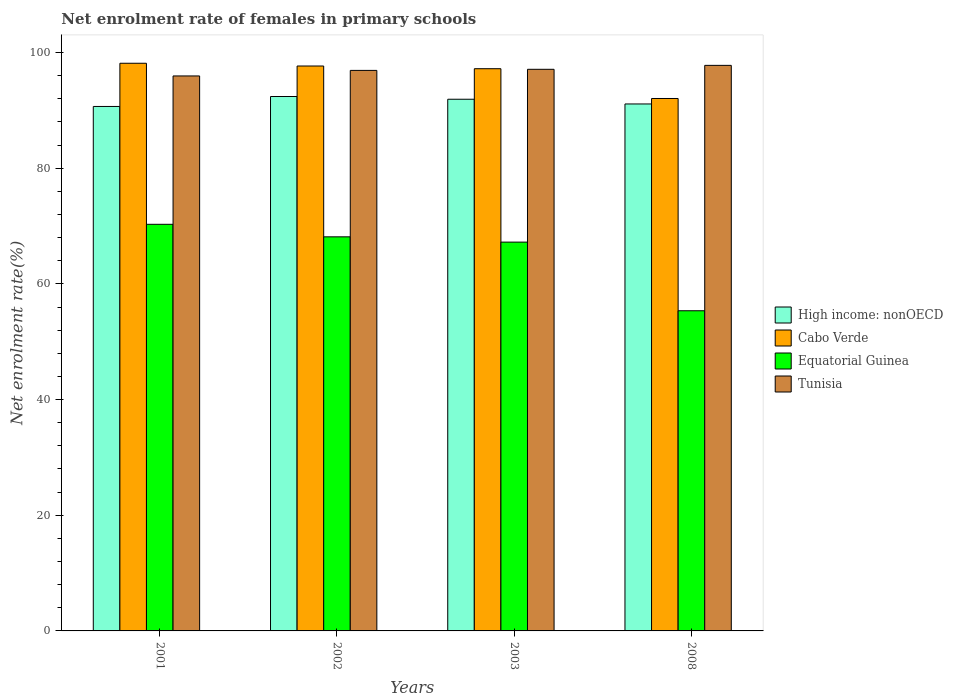Are the number of bars per tick equal to the number of legend labels?
Offer a very short reply. Yes. How many bars are there on the 1st tick from the left?
Provide a succinct answer. 4. How many bars are there on the 2nd tick from the right?
Offer a very short reply. 4. What is the label of the 3rd group of bars from the left?
Your answer should be compact. 2003. In how many cases, is the number of bars for a given year not equal to the number of legend labels?
Your answer should be compact. 0. What is the net enrolment rate of females in primary schools in Cabo Verde in 2008?
Ensure brevity in your answer.  92.05. Across all years, what is the maximum net enrolment rate of females in primary schools in Cabo Verde?
Give a very brief answer. 98.14. Across all years, what is the minimum net enrolment rate of females in primary schools in Cabo Verde?
Provide a succinct answer. 92.05. In which year was the net enrolment rate of females in primary schools in Cabo Verde maximum?
Your response must be concise. 2001. What is the total net enrolment rate of females in primary schools in Equatorial Guinea in the graph?
Your answer should be compact. 261. What is the difference between the net enrolment rate of females in primary schools in Tunisia in 2003 and that in 2008?
Offer a terse response. -0.68. What is the difference between the net enrolment rate of females in primary schools in Cabo Verde in 2001 and the net enrolment rate of females in primary schools in Tunisia in 2002?
Your answer should be very brief. 1.24. What is the average net enrolment rate of females in primary schools in Tunisia per year?
Provide a succinct answer. 96.93. In the year 2008, what is the difference between the net enrolment rate of females in primary schools in High income: nonOECD and net enrolment rate of females in primary schools in Tunisia?
Your answer should be compact. -6.67. In how many years, is the net enrolment rate of females in primary schools in Equatorial Guinea greater than 92 %?
Your answer should be compact. 0. What is the ratio of the net enrolment rate of females in primary schools in Cabo Verde in 2001 to that in 2003?
Provide a succinct answer. 1.01. Is the net enrolment rate of females in primary schools in Equatorial Guinea in 2001 less than that in 2002?
Ensure brevity in your answer.  No. What is the difference between the highest and the second highest net enrolment rate of females in primary schools in Equatorial Guinea?
Your answer should be very brief. 2.17. What is the difference between the highest and the lowest net enrolment rate of females in primary schools in Tunisia?
Your answer should be compact. 1.83. Is the sum of the net enrolment rate of females in primary schools in Tunisia in 2003 and 2008 greater than the maximum net enrolment rate of females in primary schools in Cabo Verde across all years?
Ensure brevity in your answer.  Yes. What does the 2nd bar from the left in 2003 represents?
Make the answer very short. Cabo Verde. What does the 4th bar from the right in 2008 represents?
Make the answer very short. High income: nonOECD. Are all the bars in the graph horizontal?
Offer a terse response. No. How many years are there in the graph?
Your answer should be compact. 4. Does the graph contain any zero values?
Make the answer very short. No. How are the legend labels stacked?
Your answer should be compact. Vertical. What is the title of the graph?
Ensure brevity in your answer.  Net enrolment rate of females in primary schools. Does "Paraguay" appear as one of the legend labels in the graph?
Your response must be concise. No. What is the label or title of the X-axis?
Offer a very short reply. Years. What is the label or title of the Y-axis?
Ensure brevity in your answer.  Net enrolment rate(%). What is the Net enrolment rate(%) in High income: nonOECD in 2001?
Provide a short and direct response. 90.67. What is the Net enrolment rate(%) of Cabo Verde in 2001?
Offer a terse response. 98.14. What is the Net enrolment rate(%) of Equatorial Guinea in 2001?
Keep it short and to the point. 70.3. What is the Net enrolment rate(%) in Tunisia in 2001?
Offer a very short reply. 95.95. What is the Net enrolment rate(%) in High income: nonOECD in 2002?
Provide a short and direct response. 92.39. What is the Net enrolment rate(%) in Cabo Verde in 2002?
Provide a short and direct response. 97.66. What is the Net enrolment rate(%) in Equatorial Guinea in 2002?
Make the answer very short. 68.13. What is the Net enrolment rate(%) in Tunisia in 2002?
Your response must be concise. 96.9. What is the Net enrolment rate(%) of High income: nonOECD in 2003?
Make the answer very short. 91.92. What is the Net enrolment rate(%) in Cabo Verde in 2003?
Give a very brief answer. 97.2. What is the Net enrolment rate(%) of Equatorial Guinea in 2003?
Your response must be concise. 67.22. What is the Net enrolment rate(%) in Tunisia in 2003?
Provide a succinct answer. 97.09. What is the Net enrolment rate(%) in High income: nonOECD in 2008?
Provide a succinct answer. 91.1. What is the Net enrolment rate(%) in Cabo Verde in 2008?
Keep it short and to the point. 92.05. What is the Net enrolment rate(%) of Equatorial Guinea in 2008?
Provide a succinct answer. 55.35. What is the Net enrolment rate(%) of Tunisia in 2008?
Provide a succinct answer. 97.77. Across all years, what is the maximum Net enrolment rate(%) in High income: nonOECD?
Make the answer very short. 92.39. Across all years, what is the maximum Net enrolment rate(%) of Cabo Verde?
Give a very brief answer. 98.14. Across all years, what is the maximum Net enrolment rate(%) of Equatorial Guinea?
Ensure brevity in your answer.  70.3. Across all years, what is the maximum Net enrolment rate(%) of Tunisia?
Provide a short and direct response. 97.77. Across all years, what is the minimum Net enrolment rate(%) in High income: nonOECD?
Offer a terse response. 90.67. Across all years, what is the minimum Net enrolment rate(%) of Cabo Verde?
Provide a succinct answer. 92.05. Across all years, what is the minimum Net enrolment rate(%) in Equatorial Guinea?
Keep it short and to the point. 55.35. Across all years, what is the minimum Net enrolment rate(%) in Tunisia?
Your response must be concise. 95.95. What is the total Net enrolment rate(%) of High income: nonOECD in the graph?
Your response must be concise. 366.08. What is the total Net enrolment rate(%) in Cabo Verde in the graph?
Your response must be concise. 385.05. What is the total Net enrolment rate(%) of Equatorial Guinea in the graph?
Provide a short and direct response. 261. What is the total Net enrolment rate(%) of Tunisia in the graph?
Provide a short and direct response. 387.72. What is the difference between the Net enrolment rate(%) of High income: nonOECD in 2001 and that in 2002?
Offer a very short reply. -1.72. What is the difference between the Net enrolment rate(%) of Cabo Verde in 2001 and that in 2002?
Your answer should be very brief. 0.48. What is the difference between the Net enrolment rate(%) in Equatorial Guinea in 2001 and that in 2002?
Ensure brevity in your answer.  2.17. What is the difference between the Net enrolment rate(%) in Tunisia in 2001 and that in 2002?
Ensure brevity in your answer.  -0.96. What is the difference between the Net enrolment rate(%) in High income: nonOECD in 2001 and that in 2003?
Your answer should be compact. -1.25. What is the difference between the Net enrolment rate(%) of Cabo Verde in 2001 and that in 2003?
Give a very brief answer. 0.94. What is the difference between the Net enrolment rate(%) in Equatorial Guinea in 2001 and that in 2003?
Provide a succinct answer. 3.08. What is the difference between the Net enrolment rate(%) in Tunisia in 2001 and that in 2003?
Your answer should be very brief. -1.15. What is the difference between the Net enrolment rate(%) in High income: nonOECD in 2001 and that in 2008?
Ensure brevity in your answer.  -0.43. What is the difference between the Net enrolment rate(%) in Cabo Verde in 2001 and that in 2008?
Provide a short and direct response. 6.09. What is the difference between the Net enrolment rate(%) in Equatorial Guinea in 2001 and that in 2008?
Keep it short and to the point. 14.95. What is the difference between the Net enrolment rate(%) in Tunisia in 2001 and that in 2008?
Provide a short and direct response. -1.83. What is the difference between the Net enrolment rate(%) of High income: nonOECD in 2002 and that in 2003?
Your response must be concise. 0.47. What is the difference between the Net enrolment rate(%) of Cabo Verde in 2002 and that in 2003?
Ensure brevity in your answer.  0.47. What is the difference between the Net enrolment rate(%) in Equatorial Guinea in 2002 and that in 2003?
Give a very brief answer. 0.91. What is the difference between the Net enrolment rate(%) of Tunisia in 2002 and that in 2003?
Ensure brevity in your answer.  -0.19. What is the difference between the Net enrolment rate(%) in High income: nonOECD in 2002 and that in 2008?
Ensure brevity in your answer.  1.29. What is the difference between the Net enrolment rate(%) in Cabo Verde in 2002 and that in 2008?
Provide a short and direct response. 5.62. What is the difference between the Net enrolment rate(%) of Equatorial Guinea in 2002 and that in 2008?
Provide a succinct answer. 12.78. What is the difference between the Net enrolment rate(%) in Tunisia in 2002 and that in 2008?
Keep it short and to the point. -0.87. What is the difference between the Net enrolment rate(%) of High income: nonOECD in 2003 and that in 2008?
Your answer should be very brief. 0.81. What is the difference between the Net enrolment rate(%) of Cabo Verde in 2003 and that in 2008?
Your answer should be very brief. 5.15. What is the difference between the Net enrolment rate(%) of Equatorial Guinea in 2003 and that in 2008?
Make the answer very short. 11.87. What is the difference between the Net enrolment rate(%) in Tunisia in 2003 and that in 2008?
Keep it short and to the point. -0.68. What is the difference between the Net enrolment rate(%) of High income: nonOECD in 2001 and the Net enrolment rate(%) of Cabo Verde in 2002?
Provide a succinct answer. -6.99. What is the difference between the Net enrolment rate(%) in High income: nonOECD in 2001 and the Net enrolment rate(%) in Equatorial Guinea in 2002?
Provide a short and direct response. 22.54. What is the difference between the Net enrolment rate(%) of High income: nonOECD in 2001 and the Net enrolment rate(%) of Tunisia in 2002?
Your response must be concise. -6.23. What is the difference between the Net enrolment rate(%) in Cabo Verde in 2001 and the Net enrolment rate(%) in Equatorial Guinea in 2002?
Provide a short and direct response. 30.01. What is the difference between the Net enrolment rate(%) in Cabo Verde in 2001 and the Net enrolment rate(%) in Tunisia in 2002?
Your answer should be compact. 1.24. What is the difference between the Net enrolment rate(%) of Equatorial Guinea in 2001 and the Net enrolment rate(%) of Tunisia in 2002?
Make the answer very short. -26.61. What is the difference between the Net enrolment rate(%) of High income: nonOECD in 2001 and the Net enrolment rate(%) of Cabo Verde in 2003?
Provide a short and direct response. -6.53. What is the difference between the Net enrolment rate(%) in High income: nonOECD in 2001 and the Net enrolment rate(%) in Equatorial Guinea in 2003?
Provide a short and direct response. 23.45. What is the difference between the Net enrolment rate(%) of High income: nonOECD in 2001 and the Net enrolment rate(%) of Tunisia in 2003?
Keep it short and to the point. -6.42. What is the difference between the Net enrolment rate(%) in Cabo Verde in 2001 and the Net enrolment rate(%) in Equatorial Guinea in 2003?
Your answer should be very brief. 30.92. What is the difference between the Net enrolment rate(%) in Cabo Verde in 2001 and the Net enrolment rate(%) in Tunisia in 2003?
Make the answer very short. 1.05. What is the difference between the Net enrolment rate(%) in Equatorial Guinea in 2001 and the Net enrolment rate(%) in Tunisia in 2003?
Make the answer very short. -26.79. What is the difference between the Net enrolment rate(%) in High income: nonOECD in 2001 and the Net enrolment rate(%) in Cabo Verde in 2008?
Provide a short and direct response. -1.38. What is the difference between the Net enrolment rate(%) of High income: nonOECD in 2001 and the Net enrolment rate(%) of Equatorial Guinea in 2008?
Provide a succinct answer. 35.32. What is the difference between the Net enrolment rate(%) of High income: nonOECD in 2001 and the Net enrolment rate(%) of Tunisia in 2008?
Provide a short and direct response. -7.1. What is the difference between the Net enrolment rate(%) in Cabo Verde in 2001 and the Net enrolment rate(%) in Equatorial Guinea in 2008?
Keep it short and to the point. 42.79. What is the difference between the Net enrolment rate(%) of Cabo Verde in 2001 and the Net enrolment rate(%) of Tunisia in 2008?
Your answer should be compact. 0.37. What is the difference between the Net enrolment rate(%) of Equatorial Guinea in 2001 and the Net enrolment rate(%) of Tunisia in 2008?
Provide a short and direct response. -27.48. What is the difference between the Net enrolment rate(%) of High income: nonOECD in 2002 and the Net enrolment rate(%) of Cabo Verde in 2003?
Provide a succinct answer. -4.81. What is the difference between the Net enrolment rate(%) of High income: nonOECD in 2002 and the Net enrolment rate(%) of Equatorial Guinea in 2003?
Offer a terse response. 25.17. What is the difference between the Net enrolment rate(%) in High income: nonOECD in 2002 and the Net enrolment rate(%) in Tunisia in 2003?
Make the answer very short. -4.7. What is the difference between the Net enrolment rate(%) of Cabo Verde in 2002 and the Net enrolment rate(%) of Equatorial Guinea in 2003?
Offer a terse response. 30.45. What is the difference between the Net enrolment rate(%) of Cabo Verde in 2002 and the Net enrolment rate(%) of Tunisia in 2003?
Provide a short and direct response. 0.57. What is the difference between the Net enrolment rate(%) in Equatorial Guinea in 2002 and the Net enrolment rate(%) in Tunisia in 2003?
Give a very brief answer. -28.96. What is the difference between the Net enrolment rate(%) in High income: nonOECD in 2002 and the Net enrolment rate(%) in Cabo Verde in 2008?
Ensure brevity in your answer.  0.34. What is the difference between the Net enrolment rate(%) of High income: nonOECD in 2002 and the Net enrolment rate(%) of Equatorial Guinea in 2008?
Provide a succinct answer. 37.04. What is the difference between the Net enrolment rate(%) of High income: nonOECD in 2002 and the Net enrolment rate(%) of Tunisia in 2008?
Provide a succinct answer. -5.38. What is the difference between the Net enrolment rate(%) of Cabo Verde in 2002 and the Net enrolment rate(%) of Equatorial Guinea in 2008?
Your answer should be compact. 42.31. What is the difference between the Net enrolment rate(%) of Cabo Verde in 2002 and the Net enrolment rate(%) of Tunisia in 2008?
Your response must be concise. -0.11. What is the difference between the Net enrolment rate(%) of Equatorial Guinea in 2002 and the Net enrolment rate(%) of Tunisia in 2008?
Ensure brevity in your answer.  -29.64. What is the difference between the Net enrolment rate(%) in High income: nonOECD in 2003 and the Net enrolment rate(%) in Cabo Verde in 2008?
Ensure brevity in your answer.  -0.13. What is the difference between the Net enrolment rate(%) in High income: nonOECD in 2003 and the Net enrolment rate(%) in Equatorial Guinea in 2008?
Your response must be concise. 36.57. What is the difference between the Net enrolment rate(%) of High income: nonOECD in 2003 and the Net enrolment rate(%) of Tunisia in 2008?
Give a very brief answer. -5.86. What is the difference between the Net enrolment rate(%) of Cabo Verde in 2003 and the Net enrolment rate(%) of Equatorial Guinea in 2008?
Ensure brevity in your answer.  41.85. What is the difference between the Net enrolment rate(%) in Cabo Verde in 2003 and the Net enrolment rate(%) in Tunisia in 2008?
Your answer should be compact. -0.58. What is the difference between the Net enrolment rate(%) in Equatorial Guinea in 2003 and the Net enrolment rate(%) in Tunisia in 2008?
Ensure brevity in your answer.  -30.56. What is the average Net enrolment rate(%) in High income: nonOECD per year?
Give a very brief answer. 91.52. What is the average Net enrolment rate(%) of Cabo Verde per year?
Your response must be concise. 96.26. What is the average Net enrolment rate(%) of Equatorial Guinea per year?
Keep it short and to the point. 65.25. What is the average Net enrolment rate(%) of Tunisia per year?
Your answer should be very brief. 96.93. In the year 2001, what is the difference between the Net enrolment rate(%) in High income: nonOECD and Net enrolment rate(%) in Cabo Verde?
Your answer should be very brief. -7.47. In the year 2001, what is the difference between the Net enrolment rate(%) of High income: nonOECD and Net enrolment rate(%) of Equatorial Guinea?
Offer a very short reply. 20.37. In the year 2001, what is the difference between the Net enrolment rate(%) of High income: nonOECD and Net enrolment rate(%) of Tunisia?
Provide a succinct answer. -5.27. In the year 2001, what is the difference between the Net enrolment rate(%) of Cabo Verde and Net enrolment rate(%) of Equatorial Guinea?
Ensure brevity in your answer.  27.84. In the year 2001, what is the difference between the Net enrolment rate(%) of Cabo Verde and Net enrolment rate(%) of Tunisia?
Your answer should be compact. 2.19. In the year 2001, what is the difference between the Net enrolment rate(%) of Equatorial Guinea and Net enrolment rate(%) of Tunisia?
Provide a succinct answer. -25.65. In the year 2002, what is the difference between the Net enrolment rate(%) in High income: nonOECD and Net enrolment rate(%) in Cabo Verde?
Keep it short and to the point. -5.27. In the year 2002, what is the difference between the Net enrolment rate(%) in High income: nonOECD and Net enrolment rate(%) in Equatorial Guinea?
Offer a terse response. 24.26. In the year 2002, what is the difference between the Net enrolment rate(%) in High income: nonOECD and Net enrolment rate(%) in Tunisia?
Provide a succinct answer. -4.51. In the year 2002, what is the difference between the Net enrolment rate(%) of Cabo Verde and Net enrolment rate(%) of Equatorial Guinea?
Keep it short and to the point. 29.53. In the year 2002, what is the difference between the Net enrolment rate(%) in Cabo Verde and Net enrolment rate(%) in Tunisia?
Your answer should be compact. 0.76. In the year 2002, what is the difference between the Net enrolment rate(%) in Equatorial Guinea and Net enrolment rate(%) in Tunisia?
Ensure brevity in your answer.  -28.77. In the year 2003, what is the difference between the Net enrolment rate(%) of High income: nonOECD and Net enrolment rate(%) of Cabo Verde?
Keep it short and to the point. -5.28. In the year 2003, what is the difference between the Net enrolment rate(%) of High income: nonOECD and Net enrolment rate(%) of Equatorial Guinea?
Offer a terse response. 24.7. In the year 2003, what is the difference between the Net enrolment rate(%) in High income: nonOECD and Net enrolment rate(%) in Tunisia?
Provide a succinct answer. -5.18. In the year 2003, what is the difference between the Net enrolment rate(%) of Cabo Verde and Net enrolment rate(%) of Equatorial Guinea?
Provide a short and direct response. 29.98. In the year 2003, what is the difference between the Net enrolment rate(%) in Cabo Verde and Net enrolment rate(%) in Tunisia?
Offer a terse response. 0.1. In the year 2003, what is the difference between the Net enrolment rate(%) of Equatorial Guinea and Net enrolment rate(%) of Tunisia?
Give a very brief answer. -29.88. In the year 2008, what is the difference between the Net enrolment rate(%) of High income: nonOECD and Net enrolment rate(%) of Cabo Verde?
Your response must be concise. -0.94. In the year 2008, what is the difference between the Net enrolment rate(%) in High income: nonOECD and Net enrolment rate(%) in Equatorial Guinea?
Provide a short and direct response. 35.75. In the year 2008, what is the difference between the Net enrolment rate(%) in High income: nonOECD and Net enrolment rate(%) in Tunisia?
Provide a short and direct response. -6.67. In the year 2008, what is the difference between the Net enrolment rate(%) in Cabo Verde and Net enrolment rate(%) in Equatorial Guinea?
Ensure brevity in your answer.  36.7. In the year 2008, what is the difference between the Net enrolment rate(%) in Cabo Verde and Net enrolment rate(%) in Tunisia?
Provide a succinct answer. -5.73. In the year 2008, what is the difference between the Net enrolment rate(%) in Equatorial Guinea and Net enrolment rate(%) in Tunisia?
Ensure brevity in your answer.  -42.42. What is the ratio of the Net enrolment rate(%) of High income: nonOECD in 2001 to that in 2002?
Your response must be concise. 0.98. What is the ratio of the Net enrolment rate(%) of Equatorial Guinea in 2001 to that in 2002?
Keep it short and to the point. 1.03. What is the ratio of the Net enrolment rate(%) of High income: nonOECD in 2001 to that in 2003?
Keep it short and to the point. 0.99. What is the ratio of the Net enrolment rate(%) of Cabo Verde in 2001 to that in 2003?
Give a very brief answer. 1.01. What is the ratio of the Net enrolment rate(%) in Equatorial Guinea in 2001 to that in 2003?
Your response must be concise. 1.05. What is the ratio of the Net enrolment rate(%) in Tunisia in 2001 to that in 2003?
Your response must be concise. 0.99. What is the ratio of the Net enrolment rate(%) of Cabo Verde in 2001 to that in 2008?
Give a very brief answer. 1.07. What is the ratio of the Net enrolment rate(%) of Equatorial Guinea in 2001 to that in 2008?
Make the answer very short. 1.27. What is the ratio of the Net enrolment rate(%) in Tunisia in 2001 to that in 2008?
Give a very brief answer. 0.98. What is the ratio of the Net enrolment rate(%) of Cabo Verde in 2002 to that in 2003?
Your answer should be very brief. 1. What is the ratio of the Net enrolment rate(%) in Equatorial Guinea in 2002 to that in 2003?
Give a very brief answer. 1.01. What is the ratio of the Net enrolment rate(%) of Tunisia in 2002 to that in 2003?
Provide a short and direct response. 1. What is the ratio of the Net enrolment rate(%) in High income: nonOECD in 2002 to that in 2008?
Provide a succinct answer. 1.01. What is the ratio of the Net enrolment rate(%) in Cabo Verde in 2002 to that in 2008?
Provide a succinct answer. 1.06. What is the ratio of the Net enrolment rate(%) in Equatorial Guinea in 2002 to that in 2008?
Your response must be concise. 1.23. What is the ratio of the Net enrolment rate(%) in High income: nonOECD in 2003 to that in 2008?
Offer a terse response. 1.01. What is the ratio of the Net enrolment rate(%) of Cabo Verde in 2003 to that in 2008?
Give a very brief answer. 1.06. What is the ratio of the Net enrolment rate(%) in Equatorial Guinea in 2003 to that in 2008?
Make the answer very short. 1.21. What is the difference between the highest and the second highest Net enrolment rate(%) of High income: nonOECD?
Your response must be concise. 0.47. What is the difference between the highest and the second highest Net enrolment rate(%) in Cabo Verde?
Keep it short and to the point. 0.48. What is the difference between the highest and the second highest Net enrolment rate(%) in Equatorial Guinea?
Make the answer very short. 2.17. What is the difference between the highest and the second highest Net enrolment rate(%) in Tunisia?
Keep it short and to the point. 0.68. What is the difference between the highest and the lowest Net enrolment rate(%) of High income: nonOECD?
Offer a very short reply. 1.72. What is the difference between the highest and the lowest Net enrolment rate(%) in Cabo Verde?
Offer a very short reply. 6.09. What is the difference between the highest and the lowest Net enrolment rate(%) in Equatorial Guinea?
Your answer should be compact. 14.95. What is the difference between the highest and the lowest Net enrolment rate(%) of Tunisia?
Provide a succinct answer. 1.83. 